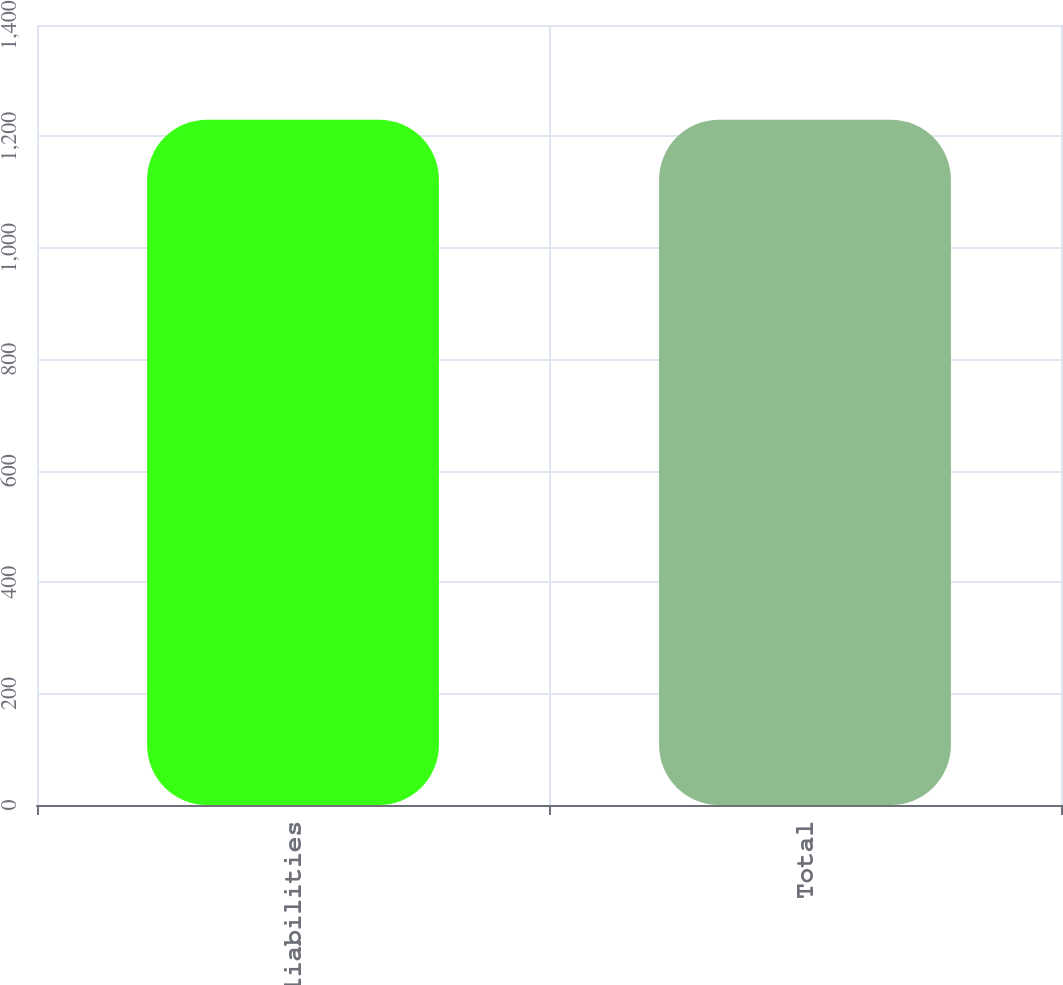<chart> <loc_0><loc_0><loc_500><loc_500><bar_chart><fcel>Other liabilities<fcel>Total<nl><fcel>1230<fcel>1230.1<nl></chart> 